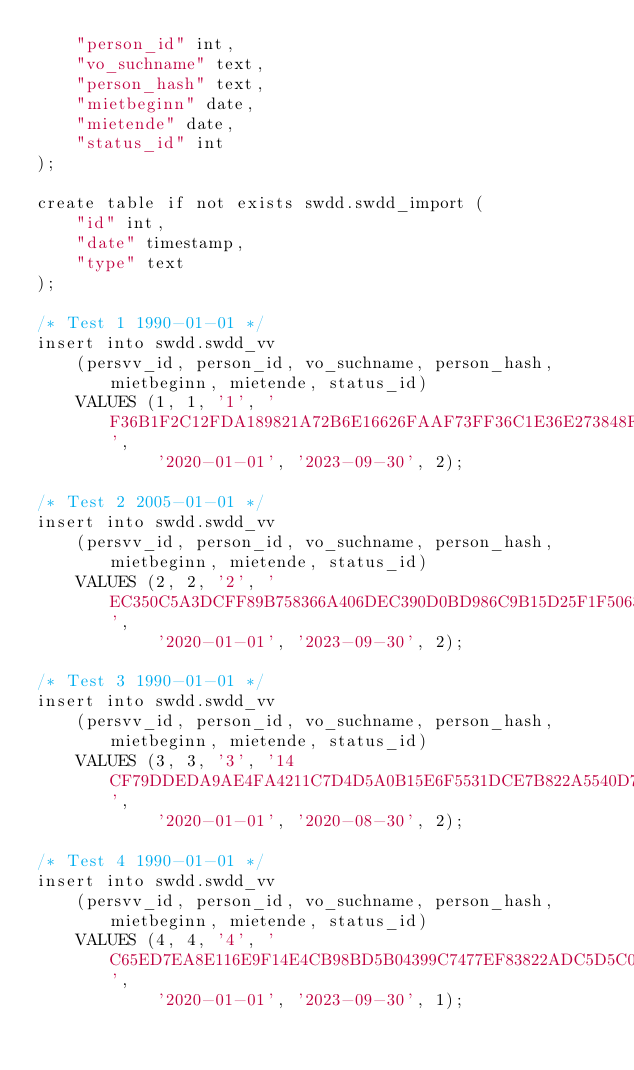<code> <loc_0><loc_0><loc_500><loc_500><_SQL_>    "person_id" int,
    "vo_suchname" text,
    "person_hash" text,
    "mietbeginn" date,
    "mietende" date,
    "status_id" int
);

create table if not exists swdd.swdd_import (
    "id" int,
    "date" timestamp,
    "type" text
);

/* Test 1 1990-01-01 */
insert into swdd.swdd_vv
    (persvv_id, person_id, vo_suchname, person_hash, mietbeginn, mietende, status_id)
    VALUES (1, 1, '1', 'F36B1F2C12FDA189821A72B6E16626FAAF73FF36C1E36E273848F1980B5D1EE9858330F528661AE724F5F52070A54802623AD50AE0A29E12ED184E4CD3DCF9C3',
            '2020-01-01', '2023-09-30', 2);

/* Test 2 2005-01-01 */
insert into swdd.swdd_vv
    (persvv_id, person_id, vo_suchname, person_hash, mietbeginn, mietende, status_id)
    VALUES (2, 2, '2', 'EC350C5A3DCFF89B758366A406DEC390D0BD986C9B15D25F1F5063EBFB4B22D18B16D908B89E9F7E21506544533A2DBCFCABCDA2BA927BCB95B96FAE799D9598',
            '2020-01-01', '2023-09-30', 2);

/* Test 3 1990-01-01 */
insert into swdd.swdd_vv
    (persvv_id, person_id, vo_suchname, person_hash, mietbeginn, mietende, status_id)
    VALUES (3, 3, '3', '14CF79DDEDA9AE4FA4211C7D4D5A0B15E6F5531DCE7B822A5540D7977B311BAE10E9F8A4614AF417A9C32C3EAF0D13CB7F30868A76844C9D1E40AD0E320CB852',
            '2020-01-01', '2020-08-30', 2);

/* Test 4 1990-01-01 */
insert into swdd.swdd_vv
    (persvv_id, person_id, vo_suchname, person_hash, mietbeginn, mietende, status_id)
    VALUES (4, 4, '4', 'C65ED7EA8E116E9F14E4CB98BD5B04399C7477EF83822ADC5D5C0E20C1FA7DC31C1033ED6DE0A98CB9FF9FA9EA86C5B1ABFF4ED5C2C334227699C5133A544760',
            '2020-01-01', '2023-09-30', 1);

</code> 